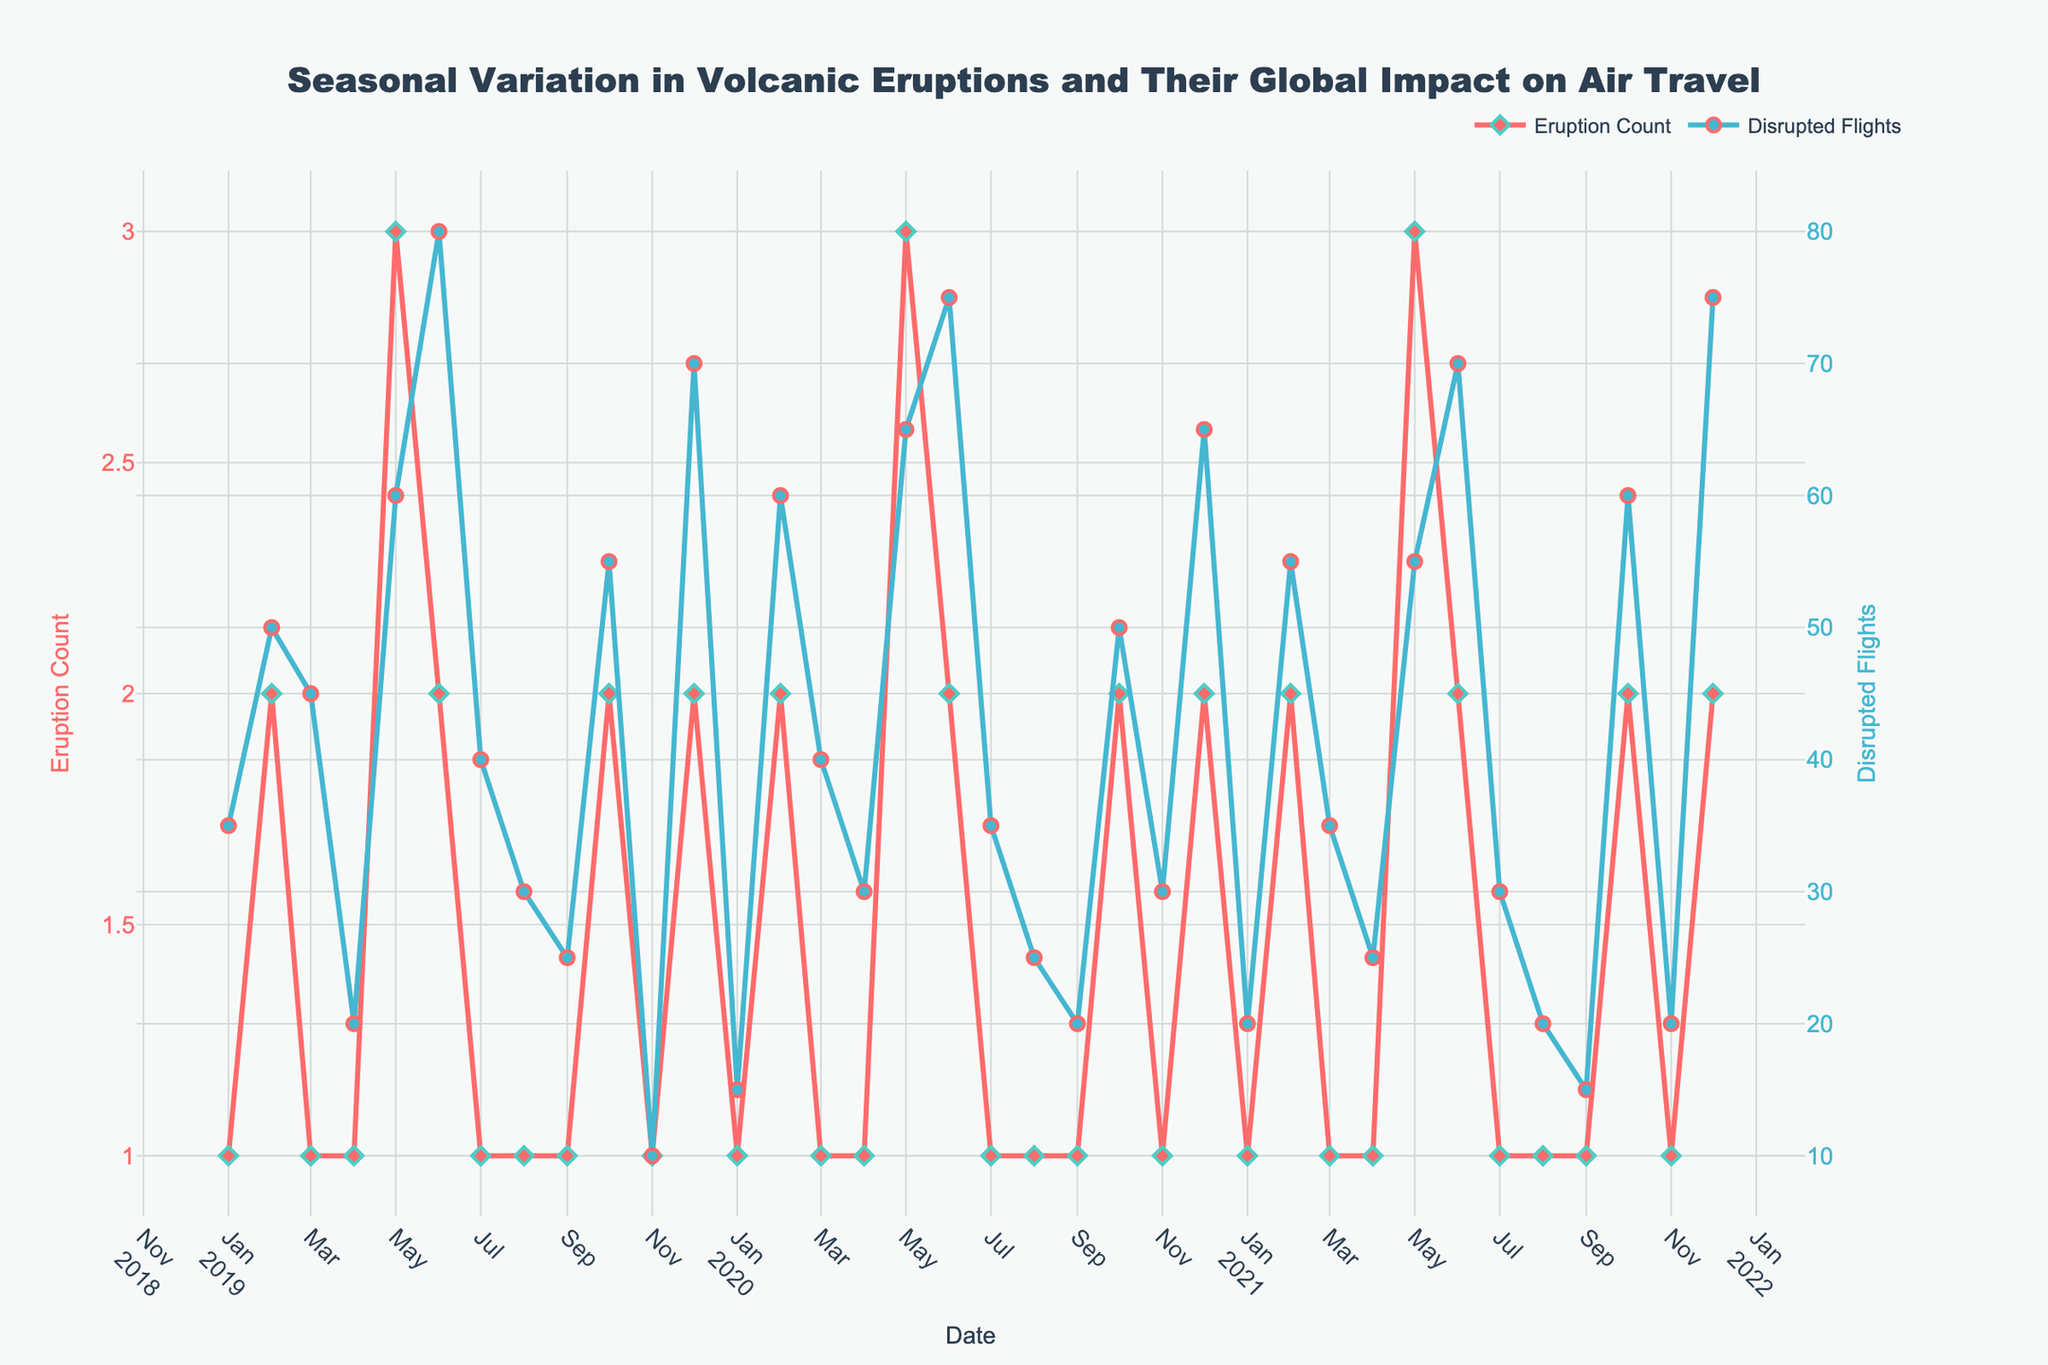What's the title of the plot? The title of the plot is located at the top center of the figure and reads: "Seasonal Variation in Volcanic Eruptions and Their Global Impact on Air Travel".
Answer: Seasonal Variation in Volcanic Eruptions and Their Global Impact on Air Travel What are the two main y-axis metrics in the plot? The left y-axis represents "Eruption Count," and the right y-axis represents "Disrupted Flights," as labeled on the plot.
Answer: Eruption Count, Disrupted Flights Which month and year saw the highest number of disrupted flights, and how many flights were disrupted? By examining the disrupted flights trace, December 2021 has the highest peak in the series for disrupted flights, totaling 75 flights.
Answer: December 2021, 75 flights What pattern can you observe in Mount Etna's eruption counts over the three years? The eruption count for Mount Etna peaks in December and February for each year from 2019 to 2021, and it has a noticeable up-and-down pattern repeated every year.
Answer: Peaks in December and February every year How many eruptions were recorded in August 2019 and August 2020 combined? Count the eruptions for August 2019 and August 2020: both months have 1 eruption each. Summing these gives 1 + 1 = 2 eruptions.
Answer: 2 eruptions Which volcano had the most consistent number of eruptions across the given time period, and what is this number? Kilauea had the most consistent number of eruptions, with 3 eruptions each May and 2 each June from 2019 to 2021.
Answer: Kilauea, consistent 3 in May and 2 in June Is there any observable correlation between the number of eruptions and the number of disrupted flights? Higher eruption counts often correlate with higher disrupted flights, seen in months with peaks, such as May and December each year. Correlation can be visualized by the simultaneous peaks in both metrics.
Answer: Yes, higher eruptions often lead to more disrupted flights In which month and year was the highest eruption count recorded, and what was the value? May 2019, May 2020, and May 2021 each recorded the highest eruption count with 3 eruptions each, peaking visually on the plot.
Answer: May 2019, May 2020, May 2021; 3 eruptions How do the disrupted flights in November 2020 compare to those in November 2019? November 2019 has 10 disrupted flights, and November 2020 has 30 disrupted flights, indicating that the disrupted flights tripled in November 2020 compared to November 2019.
Answer: Increased by 20 flights 